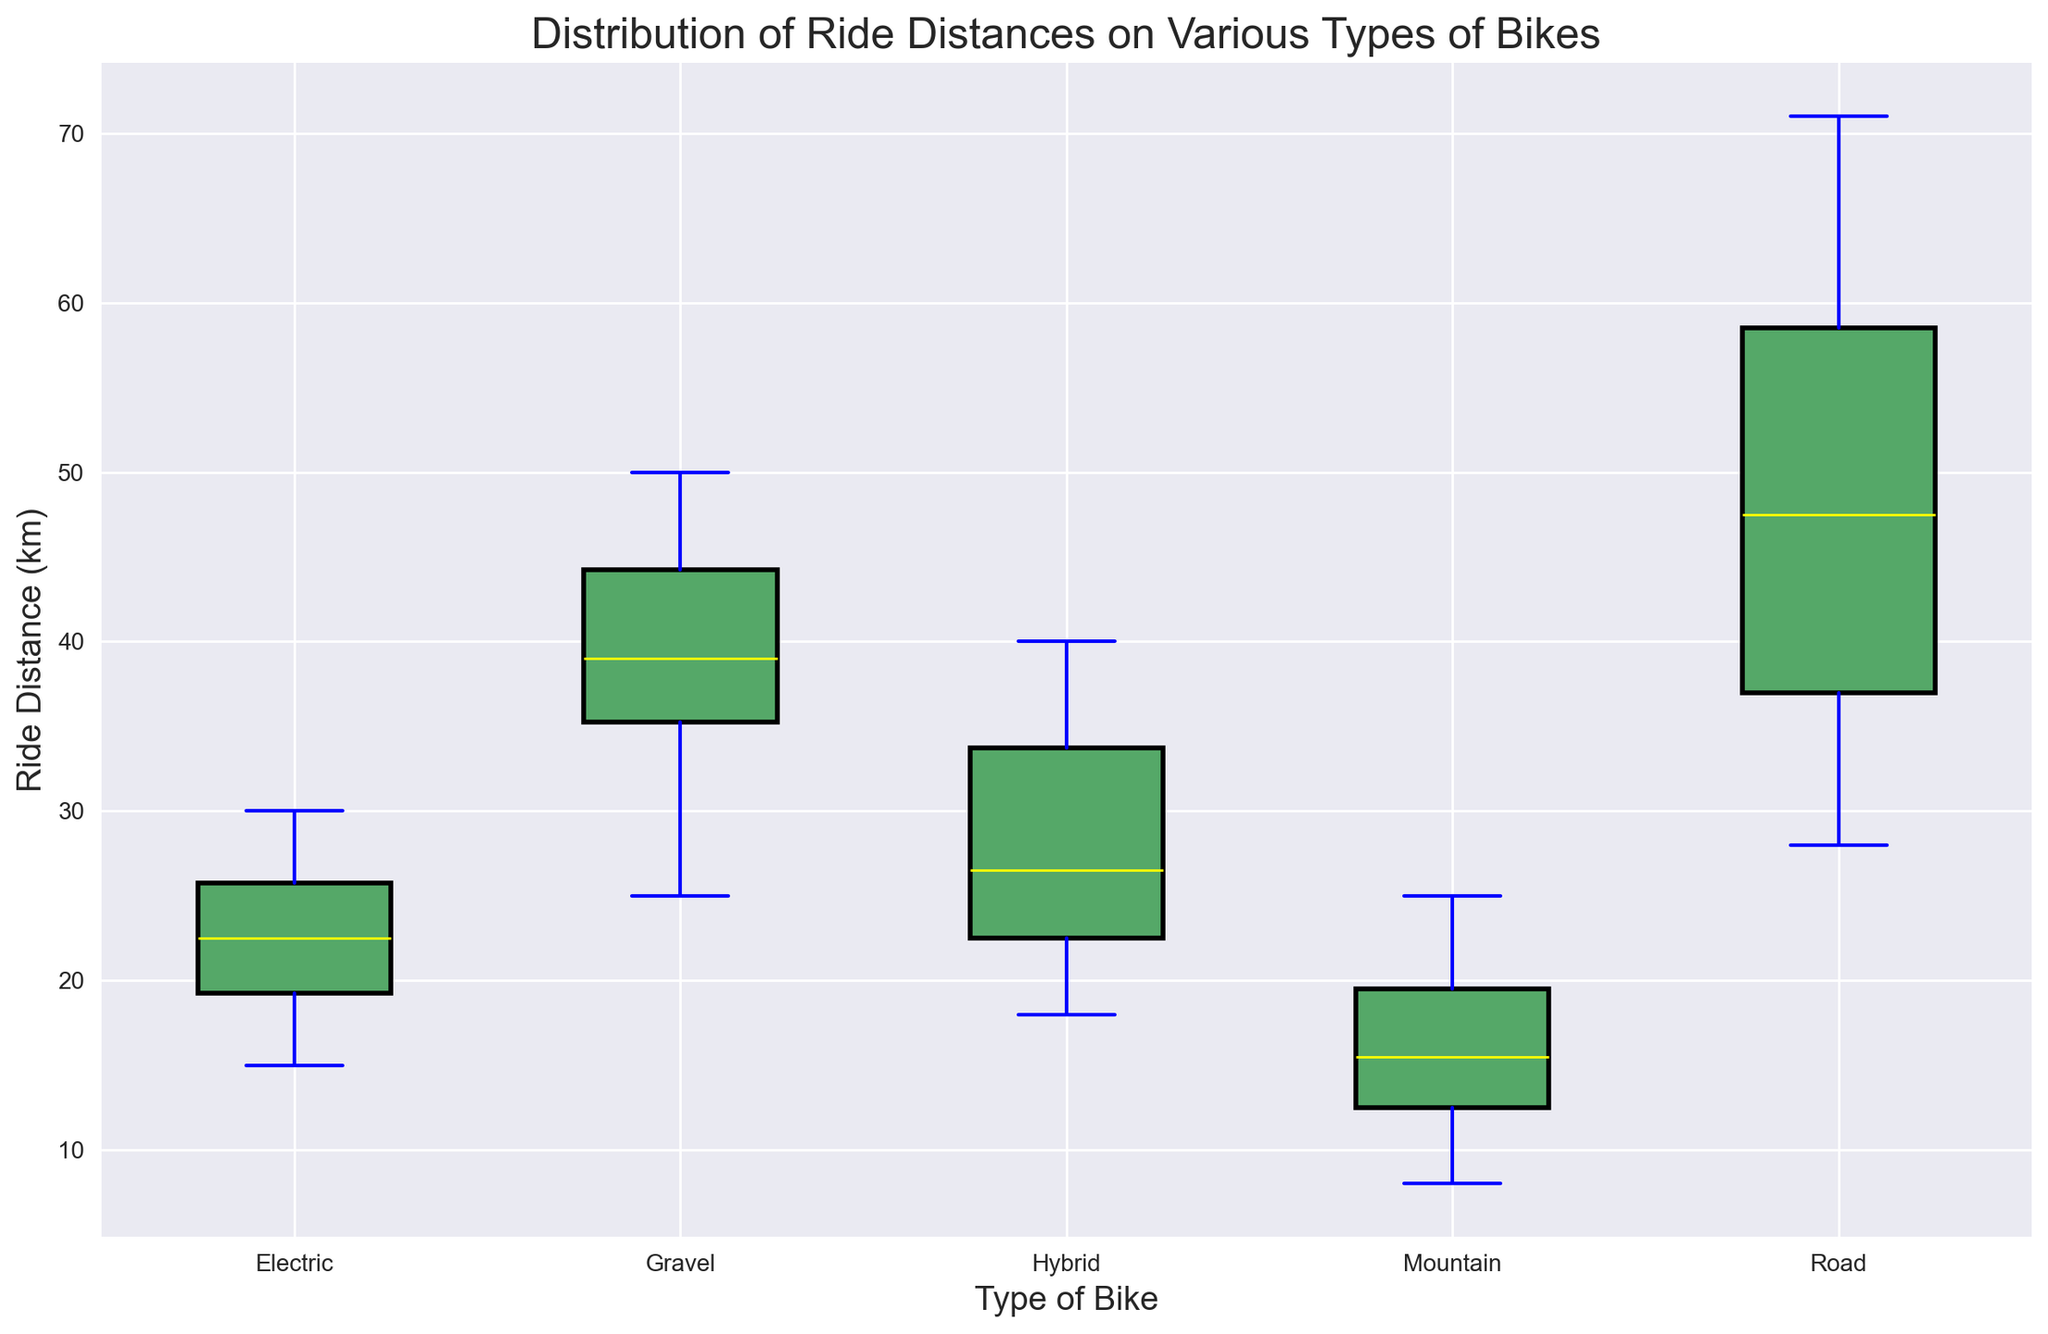What is the median ride distance for Electric bikes? To find the median, locate the center value of the sorted ride distances for Electric bikes. The distances are 15, 18, 19, 20, 22, 23, 25, 26, 27, 30. The middle values are 22 and 23, so the median is (22+23)/2
Answer: 22.5 Which type of bike has the highest median ride distance? Compare the median ride distances across all types. The medians are visually indicated by the yellow lines in the boxes, with Road bikes having the highest median.
Answer: Road Which type of bike has the smallest range of ride distances? The range is the difference between the maximum and minimum values. The whiskers indicate these extremes. Mountain bikes have the shortest whiskers, hence the smallest range.
Answer: Mountain How many types of bikes have a median ride distance between 20 and 30 km? Examine the yellow median lines across the box plots. Electric, Hybrid, and Gravel bikes all have medians within this range.
Answer: 3 Which type of bike shows the widest variability in ride distances? Variability is indicated by the length of the box and whiskers. Road bikes have the longest whiskers and box length, indicating the widest variability.
Answer: Road Is the median ride distance for Hybrid bikes greater than the median for Electric bikes? Compare the yellow lines for Hybrid and Electric bikes. The Hybrid median is higher than the Electric median.
Answer: Yes What is the interquartile range (IQR) of ride distances for Road bikes? IQR is the difference between the 75th percentile (top of the box) and the 25th percentile (bottom of the box). Measure these distances for Road bikes.
Answer: (actual values from figure) Which type of bike tends to cover the shortest distances? Look at the position of the lower whiskers for all types. Mountain bikes consistently have lower ride distances.
Answer: Mountain Which bike type has the highest upper whisker value? The upper whisker extends to the highest non-outlier value. Road bikes have the highest upper whisker.
Answer: Road Are there any outliers in the ride distances for Mountain bikes? Outliers are often depicted as individual points outside the whiskers. Check if there are red points outside the whiskers for Mountain bikes.
Answer: No 